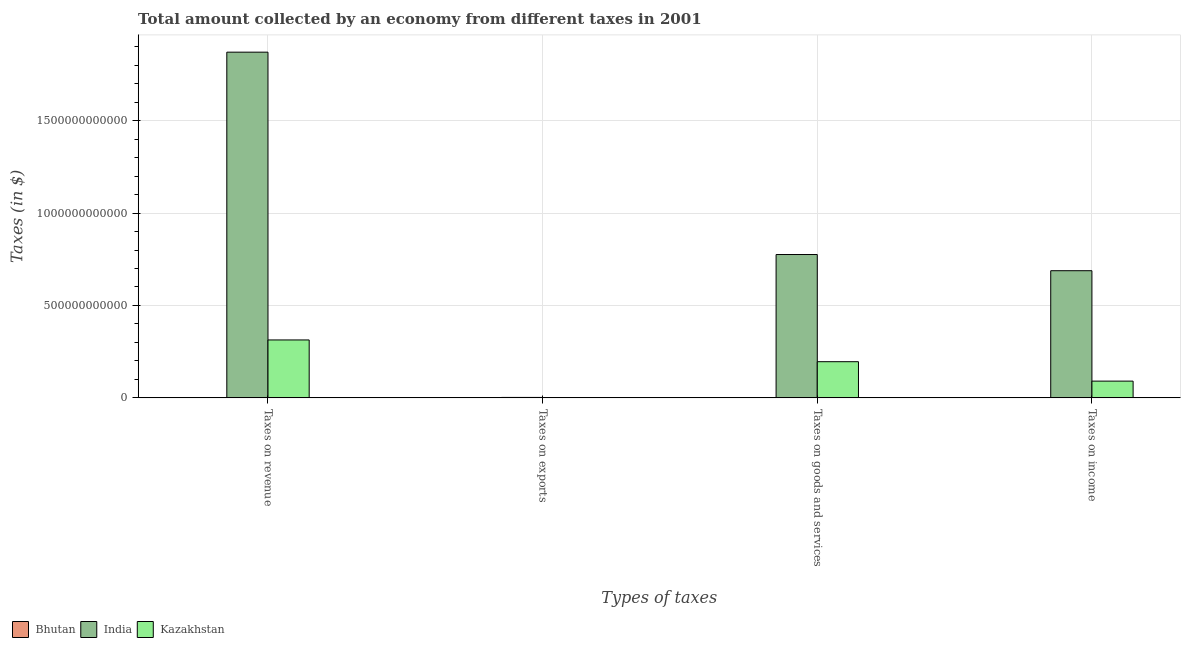How many groups of bars are there?
Keep it short and to the point. 4. Are the number of bars on each tick of the X-axis equal?
Make the answer very short. Yes. How many bars are there on the 1st tick from the left?
Your answer should be compact. 3. How many bars are there on the 4th tick from the right?
Ensure brevity in your answer.  3. What is the label of the 1st group of bars from the left?
Keep it short and to the point. Taxes on revenue. What is the amount collected as tax on exports in Bhutan?
Your answer should be compact. 1.32e+07. Across all countries, what is the maximum amount collected as tax on income?
Give a very brief answer. 6.88e+11. Across all countries, what is the minimum amount collected as tax on goods?
Your response must be concise. 5.46e+08. In which country was the amount collected as tax on exports maximum?
Your response must be concise. India. In which country was the amount collected as tax on revenue minimum?
Keep it short and to the point. Bhutan. What is the total amount collected as tax on exports in the graph?
Offer a terse response. 3.46e+09. What is the difference between the amount collected as tax on income in Kazakhstan and that in Bhutan?
Your answer should be very brief. 8.95e+1. What is the difference between the amount collected as tax on goods in Bhutan and the amount collected as tax on income in Kazakhstan?
Your answer should be very brief. -9.01e+1. What is the average amount collected as tax on revenue per country?
Give a very brief answer. 7.29e+11. What is the difference between the amount collected as tax on goods and amount collected as tax on exports in Bhutan?
Your answer should be compact. 5.33e+08. What is the ratio of the amount collected as tax on exports in Kazakhstan to that in India?
Provide a succinct answer. 0.45. Is the amount collected as tax on exports in India less than that in Kazakhstan?
Your response must be concise. No. What is the difference between the highest and the second highest amount collected as tax on exports?
Your answer should be compact. 1.30e+09. What is the difference between the highest and the lowest amount collected as tax on revenue?
Make the answer very short. 1.87e+12. Is the sum of the amount collected as tax on goods in Bhutan and India greater than the maximum amount collected as tax on income across all countries?
Give a very brief answer. Yes. Is it the case that in every country, the sum of the amount collected as tax on goods and amount collected as tax on income is greater than the sum of amount collected as tax on exports and amount collected as tax on revenue?
Your response must be concise. No. What does the 2nd bar from the left in Taxes on exports represents?
Provide a succinct answer. India. What does the 1st bar from the right in Taxes on revenue represents?
Provide a succinct answer. Kazakhstan. How many bars are there?
Offer a very short reply. 12. How many countries are there in the graph?
Provide a short and direct response. 3. What is the difference between two consecutive major ticks on the Y-axis?
Your response must be concise. 5.00e+11. Are the values on the major ticks of Y-axis written in scientific E-notation?
Provide a succinct answer. No. Where does the legend appear in the graph?
Make the answer very short. Bottom left. How are the legend labels stacked?
Ensure brevity in your answer.  Horizontal. What is the title of the graph?
Your answer should be compact. Total amount collected by an economy from different taxes in 2001. Does "Indonesia" appear as one of the legend labels in the graph?
Ensure brevity in your answer.  No. What is the label or title of the X-axis?
Give a very brief answer. Types of taxes. What is the label or title of the Y-axis?
Provide a succinct answer. Taxes (in $). What is the Taxes (in $) in Bhutan in Taxes on revenue?
Your answer should be compact. 1.92e+09. What is the Taxes (in $) in India in Taxes on revenue?
Your answer should be compact. 1.87e+12. What is the Taxes (in $) in Kazakhstan in Taxes on revenue?
Provide a short and direct response. 3.13e+11. What is the Taxes (in $) in Bhutan in Taxes on exports?
Your response must be concise. 1.32e+07. What is the Taxes (in $) of India in Taxes on exports?
Provide a succinct answer. 2.37e+09. What is the Taxes (in $) of Kazakhstan in Taxes on exports?
Give a very brief answer. 1.07e+09. What is the Taxes (in $) of Bhutan in Taxes on goods and services?
Offer a terse response. 5.46e+08. What is the Taxes (in $) of India in Taxes on goods and services?
Give a very brief answer. 7.76e+11. What is the Taxes (in $) of Kazakhstan in Taxes on goods and services?
Your answer should be compact. 1.96e+11. What is the Taxes (in $) of Bhutan in Taxes on income?
Provide a short and direct response. 1.19e+09. What is the Taxes (in $) in India in Taxes on income?
Offer a terse response. 6.88e+11. What is the Taxes (in $) in Kazakhstan in Taxes on income?
Your response must be concise. 9.07e+1. Across all Types of taxes, what is the maximum Taxes (in $) of Bhutan?
Your answer should be very brief. 1.92e+09. Across all Types of taxes, what is the maximum Taxes (in $) in India?
Provide a short and direct response. 1.87e+12. Across all Types of taxes, what is the maximum Taxes (in $) in Kazakhstan?
Give a very brief answer. 3.13e+11. Across all Types of taxes, what is the minimum Taxes (in $) of Bhutan?
Provide a succinct answer. 1.32e+07. Across all Types of taxes, what is the minimum Taxes (in $) of India?
Offer a terse response. 2.37e+09. Across all Types of taxes, what is the minimum Taxes (in $) of Kazakhstan?
Make the answer very short. 1.07e+09. What is the total Taxes (in $) in Bhutan in the graph?
Your response must be concise. 3.67e+09. What is the total Taxes (in $) of India in the graph?
Your answer should be compact. 3.34e+12. What is the total Taxes (in $) in Kazakhstan in the graph?
Give a very brief answer. 6.01e+11. What is the difference between the Taxes (in $) of Bhutan in Taxes on revenue and that in Taxes on exports?
Your response must be concise. 1.90e+09. What is the difference between the Taxes (in $) of India in Taxes on revenue and that in Taxes on exports?
Keep it short and to the point. 1.87e+12. What is the difference between the Taxes (in $) in Kazakhstan in Taxes on revenue and that in Taxes on exports?
Provide a succinct answer. 3.12e+11. What is the difference between the Taxes (in $) in Bhutan in Taxes on revenue and that in Taxes on goods and services?
Give a very brief answer. 1.37e+09. What is the difference between the Taxes (in $) of India in Taxes on revenue and that in Taxes on goods and services?
Offer a very short reply. 1.09e+12. What is the difference between the Taxes (in $) in Kazakhstan in Taxes on revenue and that in Taxes on goods and services?
Your answer should be very brief. 1.18e+11. What is the difference between the Taxes (in $) of Bhutan in Taxes on revenue and that in Taxes on income?
Give a very brief answer. 7.25e+08. What is the difference between the Taxes (in $) of India in Taxes on revenue and that in Taxes on income?
Keep it short and to the point. 1.18e+12. What is the difference between the Taxes (in $) of Kazakhstan in Taxes on revenue and that in Taxes on income?
Ensure brevity in your answer.  2.23e+11. What is the difference between the Taxes (in $) of Bhutan in Taxes on exports and that in Taxes on goods and services?
Offer a terse response. -5.33e+08. What is the difference between the Taxes (in $) of India in Taxes on exports and that in Taxes on goods and services?
Your response must be concise. -7.73e+11. What is the difference between the Taxes (in $) in Kazakhstan in Taxes on exports and that in Taxes on goods and services?
Provide a short and direct response. -1.95e+11. What is the difference between the Taxes (in $) in Bhutan in Taxes on exports and that in Taxes on income?
Make the answer very short. -1.18e+09. What is the difference between the Taxes (in $) of India in Taxes on exports and that in Taxes on income?
Your answer should be very brief. -6.86e+11. What is the difference between the Taxes (in $) in Kazakhstan in Taxes on exports and that in Taxes on income?
Offer a terse response. -8.96e+1. What is the difference between the Taxes (in $) in Bhutan in Taxes on goods and services and that in Taxes on income?
Provide a succinct answer. -6.46e+08. What is the difference between the Taxes (in $) of India in Taxes on goods and services and that in Taxes on income?
Keep it short and to the point. 8.76e+1. What is the difference between the Taxes (in $) of Kazakhstan in Taxes on goods and services and that in Taxes on income?
Offer a very short reply. 1.05e+11. What is the difference between the Taxes (in $) of Bhutan in Taxes on revenue and the Taxes (in $) of India in Taxes on exports?
Offer a terse response. -4.53e+08. What is the difference between the Taxes (in $) of Bhutan in Taxes on revenue and the Taxes (in $) of Kazakhstan in Taxes on exports?
Your answer should be very brief. 8.44e+08. What is the difference between the Taxes (in $) in India in Taxes on revenue and the Taxes (in $) in Kazakhstan in Taxes on exports?
Offer a terse response. 1.87e+12. What is the difference between the Taxes (in $) of Bhutan in Taxes on revenue and the Taxes (in $) of India in Taxes on goods and services?
Your answer should be compact. -7.74e+11. What is the difference between the Taxes (in $) in Bhutan in Taxes on revenue and the Taxes (in $) in Kazakhstan in Taxes on goods and services?
Keep it short and to the point. -1.94e+11. What is the difference between the Taxes (in $) in India in Taxes on revenue and the Taxes (in $) in Kazakhstan in Taxes on goods and services?
Make the answer very short. 1.67e+12. What is the difference between the Taxes (in $) in Bhutan in Taxes on revenue and the Taxes (in $) in India in Taxes on income?
Provide a short and direct response. -6.86e+11. What is the difference between the Taxes (in $) of Bhutan in Taxes on revenue and the Taxes (in $) of Kazakhstan in Taxes on income?
Ensure brevity in your answer.  -8.88e+1. What is the difference between the Taxes (in $) in India in Taxes on revenue and the Taxes (in $) in Kazakhstan in Taxes on income?
Give a very brief answer. 1.78e+12. What is the difference between the Taxes (in $) in Bhutan in Taxes on exports and the Taxes (in $) in India in Taxes on goods and services?
Your answer should be compact. -7.76e+11. What is the difference between the Taxes (in $) of Bhutan in Taxes on exports and the Taxes (in $) of Kazakhstan in Taxes on goods and services?
Ensure brevity in your answer.  -1.96e+11. What is the difference between the Taxes (in $) in India in Taxes on exports and the Taxes (in $) in Kazakhstan in Taxes on goods and services?
Your answer should be very brief. -1.93e+11. What is the difference between the Taxes (in $) of Bhutan in Taxes on exports and the Taxes (in $) of India in Taxes on income?
Your answer should be compact. -6.88e+11. What is the difference between the Taxes (in $) in Bhutan in Taxes on exports and the Taxes (in $) in Kazakhstan in Taxes on income?
Your response must be concise. -9.07e+1. What is the difference between the Taxes (in $) of India in Taxes on exports and the Taxes (in $) of Kazakhstan in Taxes on income?
Ensure brevity in your answer.  -8.83e+1. What is the difference between the Taxes (in $) in Bhutan in Taxes on goods and services and the Taxes (in $) in India in Taxes on income?
Make the answer very short. -6.87e+11. What is the difference between the Taxes (in $) in Bhutan in Taxes on goods and services and the Taxes (in $) in Kazakhstan in Taxes on income?
Offer a very short reply. -9.01e+1. What is the difference between the Taxes (in $) of India in Taxes on goods and services and the Taxes (in $) of Kazakhstan in Taxes on income?
Provide a succinct answer. 6.85e+11. What is the average Taxes (in $) of Bhutan per Types of taxes?
Ensure brevity in your answer.  9.17e+08. What is the average Taxes (in $) of India per Types of taxes?
Your response must be concise. 8.34e+11. What is the average Taxes (in $) in Kazakhstan per Types of taxes?
Provide a succinct answer. 1.50e+11. What is the difference between the Taxes (in $) in Bhutan and Taxes (in $) in India in Taxes on revenue?
Keep it short and to the point. -1.87e+12. What is the difference between the Taxes (in $) in Bhutan and Taxes (in $) in Kazakhstan in Taxes on revenue?
Offer a very short reply. -3.12e+11. What is the difference between the Taxes (in $) of India and Taxes (in $) of Kazakhstan in Taxes on revenue?
Your answer should be very brief. 1.56e+12. What is the difference between the Taxes (in $) of Bhutan and Taxes (in $) of India in Taxes on exports?
Make the answer very short. -2.36e+09. What is the difference between the Taxes (in $) in Bhutan and Taxes (in $) in Kazakhstan in Taxes on exports?
Ensure brevity in your answer.  -1.06e+09. What is the difference between the Taxes (in $) of India and Taxes (in $) of Kazakhstan in Taxes on exports?
Offer a terse response. 1.30e+09. What is the difference between the Taxes (in $) in Bhutan and Taxes (in $) in India in Taxes on goods and services?
Offer a terse response. -7.75e+11. What is the difference between the Taxes (in $) in Bhutan and Taxes (in $) in Kazakhstan in Taxes on goods and services?
Offer a very short reply. -1.95e+11. What is the difference between the Taxes (in $) of India and Taxes (in $) of Kazakhstan in Taxes on goods and services?
Provide a succinct answer. 5.80e+11. What is the difference between the Taxes (in $) in Bhutan and Taxes (in $) in India in Taxes on income?
Your answer should be very brief. -6.87e+11. What is the difference between the Taxes (in $) in Bhutan and Taxes (in $) in Kazakhstan in Taxes on income?
Your answer should be very brief. -8.95e+1. What is the difference between the Taxes (in $) in India and Taxes (in $) in Kazakhstan in Taxes on income?
Your answer should be very brief. 5.97e+11. What is the ratio of the Taxes (in $) in Bhutan in Taxes on revenue to that in Taxes on exports?
Provide a succinct answer. 145.22. What is the ratio of the Taxes (in $) of India in Taxes on revenue to that in Taxes on exports?
Your response must be concise. 789.28. What is the ratio of the Taxes (in $) of Kazakhstan in Taxes on revenue to that in Taxes on exports?
Offer a terse response. 292.01. What is the ratio of the Taxes (in $) in Bhutan in Taxes on revenue to that in Taxes on goods and services?
Your response must be concise. 3.51. What is the ratio of the Taxes (in $) in India in Taxes on revenue to that in Taxes on goods and services?
Provide a short and direct response. 2.41. What is the ratio of the Taxes (in $) in Kazakhstan in Taxes on revenue to that in Taxes on goods and services?
Make the answer very short. 1.6. What is the ratio of the Taxes (in $) in Bhutan in Taxes on revenue to that in Taxes on income?
Make the answer very short. 1.61. What is the ratio of the Taxes (in $) of India in Taxes on revenue to that in Taxes on income?
Offer a terse response. 2.72. What is the ratio of the Taxes (in $) in Kazakhstan in Taxes on revenue to that in Taxes on income?
Make the answer very short. 3.46. What is the ratio of the Taxes (in $) of Bhutan in Taxes on exports to that in Taxes on goods and services?
Make the answer very short. 0.02. What is the ratio of the Taxes (in $) of India in Taxes on exports to that in Taxes on goods and services?
Your answer should be very brief. 0. What is the ratio of the Taxes (in $) in Kazakhstan in Taxes on exports to that in Taxes on goods and services?
Provide a short and direct response. 0.01. What is the ratio of the Taxes (in $) in Bhutan in Taxes on exports to that in Taxes on income?
Offer a terse response. 0.01. What is the ratio of the Taxes (in $) in India in Taxes on exports to that in Taxes on income?
Your answer should be compact. 0. What is the ratio of the Taxes (in $) of Kazakhstan in Taxes on exports to that in Taxes on income?
Make the answer very short. 0.01. What is the ratio of the Taxes (in $) in Bhutan in Taxes on goods and services to that in Taxes on income?
Give a very brief answer. 0.46. What is the ratio of the Taxes (in $) of India in Taxes on goods and services to that in Taxes on income?
Keep it short and to the point. 1.13. What is the ratio of the Taxes (in $) of Kazakhstan in Taxes on goods and services to that in Taxes on income?
Your answer should be very brief. 2.16. What is the difference between the highest and the second highest Taxes (in $) of Bhutan?
Offer a terse response. 7.25e+08. What is the difference between the highest and the second highest Taxes (in $) in India?
Your answer should be very brief. 1.09e+12. What is the difference between the highest and the second highest Taxes (in $) of Kazakhstan?
Your answer should be very brief. 1.18e+11. What is the difference between the highest and the lowest Taxes (in $) of Bhutan?
Offer a terse response. 1.90e+09. What is the difference between the highest and the lowest Taxes (in $) of India?
Give a very brief answer. 1.87e+12. What is the difference between the highest and the lowest Taxes (in $) in Kazakhstan?
Ensure brevity in your answer.  3.12e+11. 